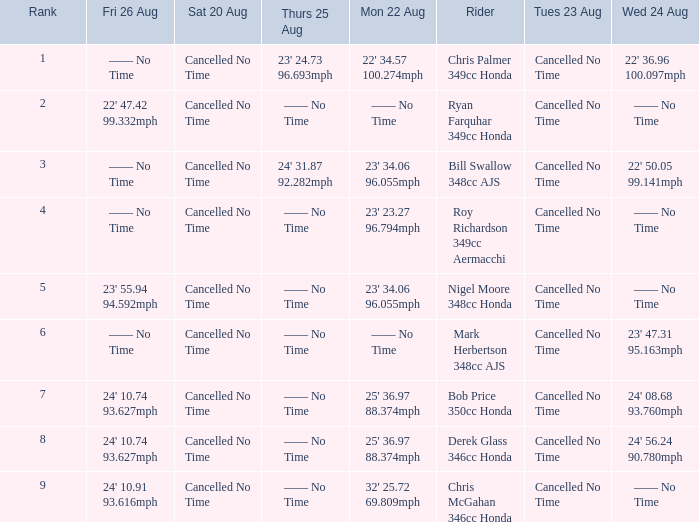Write the full table. {'header': ['Rank', 'Fri 26 Aug', 'Sat 20 Aug', 'Thurs 25 Aug', 'Mon 22 Aug', 'Rider', 'Tues 23 Aug', 'Wed 24 Aug'], 'rows': [['1', '—— No Time', 'Cancelled No Time', "23' 24.73 96.693mph", "22' 34.57 100.274mph", 'Chris Palmer 349cc Honda', 'Cancelled No Time', "22' 36.96 100.097mph"], ['2', "22' 47.42 99.332mph", 'Cancelled No Time', '—— No Time', '—— No Time', 'Ryan Farquhar 349cc Honda', 'Cancelled No Time', '—— No Time'], ['3', '—— No Time', 'Cancelled No Time', "24' 31.87 92.282mph", "23' 34.06 96.055mph", 'Bill Swallow 348cc AJS', 'Cancelled No Time', "22' 50.05 99.141mph"], ['4', '—— No Time', 'Cancelled No Time', '—— No Time', "23' 23.27 96.794mph", 'Roy Richardson 349cc Aermacchi', 'Cancelled No Time', '—— No Time'], ['5', "23' 55.94 94.592mph", 'Cancelled No Time', '—— No Time', "23' 34.06 96.055mph", 'Nigel Moore 348cc Honda', 'Cancelled No Time', '—— No Time'], ['6', '—— No Time', 'Cancelled No Time', '—— No Time', '—— No Time', 'Mark Herbertson 348cc AJS', 'Cancelled No Time', "23' 47.31 95.163mph"], ['7', "24' 10.74 93.627mph", 'Cancelled No Time', '—— No Time', "25' 36.97 88.374mph", 'Bob Price 350cc Honda', 'Cancelled No Time', "24' 08.68 93.760mph"], ['8', "24' 10.74 93.627mph", 'Cancelled No Time', '—— No Time', "25' 36.97 88.374mph", 'Derek Glass 346cc Honda', 'Cancelled No Time', "24' 56.24 90.780mph"], ['9', "24' 10.91 93.616mph", 'Cancelled No Time', '—— No Time', "32' 25.72 69.809mph", 'Chris McGahan 346cc Honda', 'Cancelled No Time', '—— No Time']]} What is every entry for Tuesday August 23 when Thursday August 25 is 24' 31.87 92.282mph? Cancelled No Time. 